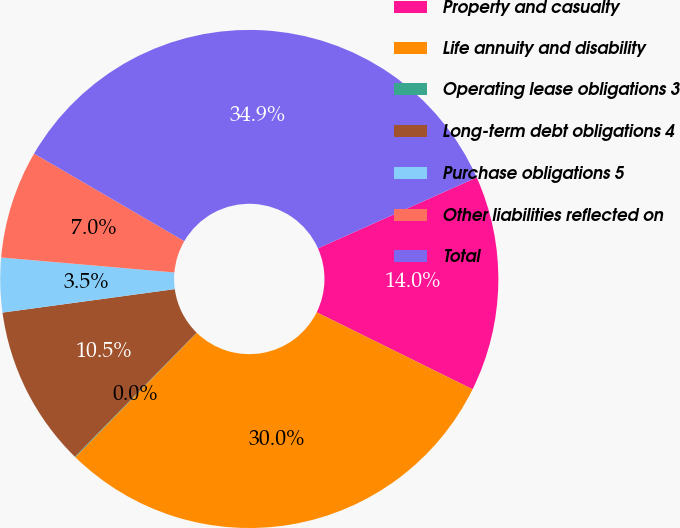Convert chart to OTSL. <chart><loc_0><loc_0><loc_500><loc_500><pie_chart><fcel>Property and casualty<fcel>Life annuity and disability<fcel>Operating lease obligations 3<fcel>Long-term debt obligations 4<fcel>Purchase obligations 5<fcel>Other liabilities reflected on<fcel>Total<nl><fcel>13.99%<fcel>30.0%<fcel>0.04%<fcel>10.5%<fcel>3.53%<fcel>7.02%<fcel>34.92%<nl></chart> 